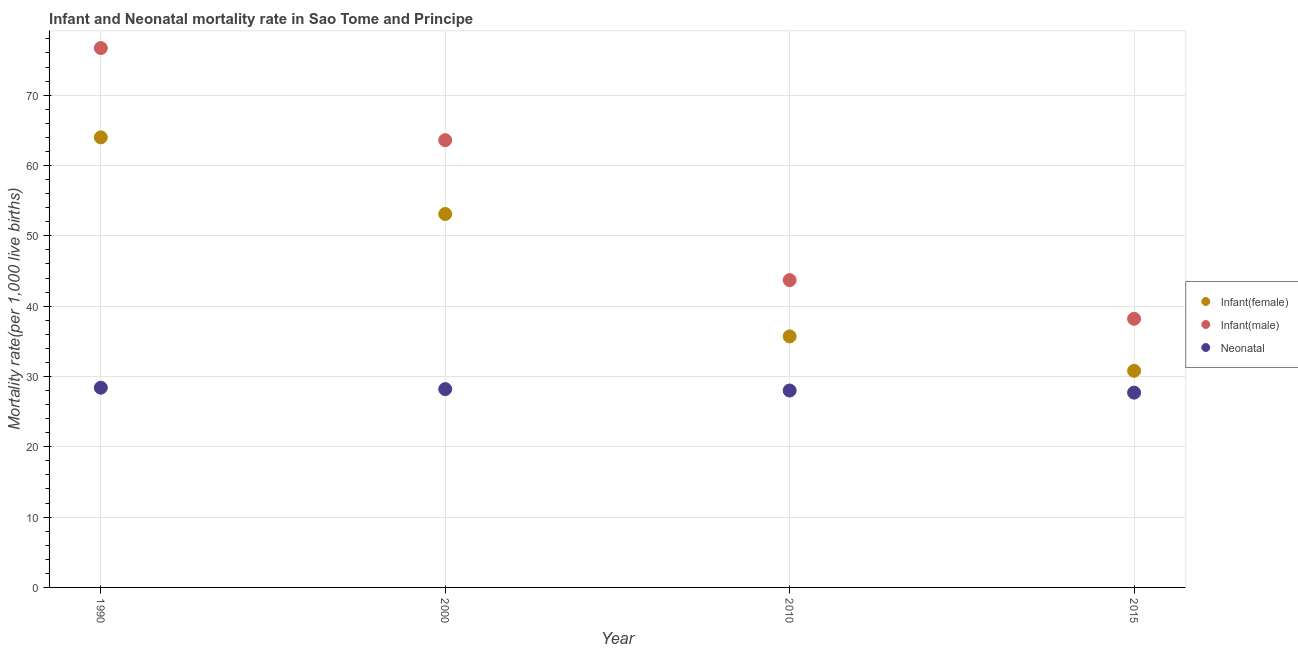Is the number of dotlines equal to the number of legend labels?
Your response must be concise. Yes. What is the infant mortality rate(male) in 2010?
Provide a succinct answer. 43.7. Across all years, what is the maximum infant mortality rate(female)?
Keep it short and to the point. 64. Across all years, what is the minimum infant mortality rate(female)?
Give a very brief answer. 30.8. In which year was the neonatal mortality rate minimum?
Give a very brief answer. 2015. What is the total infant mortality rate(female) in the graph?
Give a very brief answer. 183.6. What is the difference between the neonatal mortality rate in 2000 and that in 2010?
Your answer should be compact. 0.2. What is the difference between the infant mortality rate(female) in 2010 and the neonatal mortality rate in 1990?
Your answer should be compact. 7.3. What is the average infant mortality rate(female) per year?
Give a very brief answer. 45.9. In the year 2015, what is the difference between the neonatal mortality rate and infant mortality rate(male)?
Ensure brevity in your answer.  -10.5. What is the ratio of the neonatal mortality rate in 2000 to that in 2015?
Your answer should be compact. 1.02. What is the difference between the highest and the second highest infant mortality rate(female)?
Make the answer very short. 10.9. What is the difference between the highest and the lowest neonatal mortality rate?
Offer a very short reply. 0.7. In how many years, is the neonatal mortality rate greater than the average neonatal mortality rate taken over all years?
Your answer should be compact. 2. Is the sum of the infant mortality rate(male) in 2000 and 2015 greater than the maximum infant mortality rate(female) across all years?
Provide a short and direct response. Yes. What is the difference between two consecutive major ticks on the Y-axis?
Offer a terse response. 10. Does the graph contain any zero values?
Keep it short and to the point. No. Does the graph contain grids?
Your response must be concise. Yes. Where does the legend appear in the graph?
Ensure brevity in your answer.  Center right. How many legend labels are there?
Your response must be concise. 3. How are the legend labels stacked?
Your answer should be compact. Vertical. What is the title of the graph?
Offer a terse response. Infant and Neonatal mortality rate in Sao Tome and Principe. Does "Social insurance" appear as one of the legend labels in the graph?
Your answer should be very brief. No. What is the label or title of the Y-axis?
Your response must be concise. Mortality rate(per 1,0 live births). What is the Mortality rate(per 1,000 live births) in Infant(male) in 1990?
Ensure brevity in your answer.  76.7. What is the Mortality rate(per 1,000 live births) in Neonatal  in 1990?
Keep it short and to the point. 28.4. What is the Mortality rate(per 1,000 live births) of Infant(female) in 2000?
Provide a succinct answer. 53.1. What is the Mortality rate(per 1,000 live births) in Infant(male) in 2000?
Ensure brevity in your answer.  63.6. What is the Mortality rate(per 1,000 live births) of Neonatal  in 2000?
Give a very brief answer. 28.2. What is the Mortality rate(per 1,000 live births) in Infant(female) in 2010?
Your answer should be compact. 35.7. What is the Mortality rate(per 1,000 live births) of Infant(male) in 2010?
Keep it short and to the point. 43.7. What is the Mortality rate(per 1,000 live births) of Neonatal  in 2010?
Ensure brevity in your answer.  28. What is the Mortality rate(per 1,000 live births) of Infant(female) in 2015?
Offer a very short reply. 30.8. What is the Mortality rate(per 1,000 live births) in Infant(male) in 2015?
Your response must be concise. 38.2. What is the Mortality rate(per 1,000 live births) of Neonatal  in 2015?
Give a very brief answer. 27.7. Across all years, what is the maximum Mortality rate(per 1,000 live births) in Infant(female)?
Your answer should be compact. 64. Across all years, what is the maximum Mortality rate(per 1,000 live births) of Infant(male)?
Your answer should be very brief. 76.7. Across all years, what is the maximum Mortality rate(per 1,000 live births) in Neonatal ?
Offer a terse response. 28.4. Across all years, what is the minimum Mortality rate(per 1,000 live births) in Infant(female)?
Your answer should be compact. 30.8. Across all years, what is the minimum Mortality rate(per 1,000 live births) in Infant(male)?
Provide a succinct answer. 38.2. Across all years, what is the minimum Mortality rate(per 1,000 live births) in Neonatal ?
Your response must be concise. 27.7. What is the total Mortality rate(per 1,000 live births) of Infant(female) in the graph?
Your answer should be compact. 183.6. What is the total Mortality rate(per 1,000 live births) of Infant(male) in the graph?
Keep it short and to the point. 222.2. What is the total Mortality rate(per 1,000 live births) in Neonatal  in the graph?
Ensure brevity in your answer.  112.3. What is the difference between the Mortality rate(per 1,000 live births) of Neonatal  in 1990 and that in 2000?
Your answer should be very brief. 0.2. What is the difference between the Mortality rate(per 1,000 live births) in Infant(female) in 1990 and that in 2010?
Make the answer very short. 28.3. What is the difference between the Mortality rate(per 1,000 live births) of Neonatal  in 1990 and that in 2010?
Provide a succinct answer. 0.4. What is the difference between the Mortality rate(per 1,000 live births) in Infant(female) in 1990 and that in 2015?
Your response must be concise. 33.2. What is the difference between the Mortality rate(per 1,000 live births) of Infant(male) in 1990 and that in 2015?
Provide a short and direct response. 38.5. What is the difference between the Mortality rate(per 1,000 live births) in Neonatal  in 1990 and that in 2015?
Offer a terse response. 0.7. What is the difference between the Mortality rate(per 1,000 live births) of Neonatal  in 2000 and that in 2010?
Make the answer very short. 0.2. What is the difference between the Mortality rate(per 1,000 live births) of Infant(female) in 2000 and that in 2015?
Make the answer very short. 22.3. What is the difference between the Mortality rate(per 1,000 live births) in Infant(male) in 2000 and that in 2015?
Your answer should be compact. 25.4. What is the difference between the Mortality rate(per 1,000 live births) of Neonatal  in 2000 and that in 2015?
Provide a short and direct response. 0.5. What is the difference between the Mortality rate(per 1,000 live births) in Infant(female) in 2010 and that in 2015?
Your answer should be compact. 4.9. What is the difference between the Mortality rate(per 1,000 live births) in Infant(male) in 2010 and that in 2015?
Make the answer very short. 5.5. What is the difference between the Mortality rate(per 1,000 live births) of Neonatal  in 2010 and that in 2015?
Make the answer very short. 0.3. What is the difference between the Mortality rate(per 1,000 live births) of Infant(female) in 1990 and the Mortality rate(per 1,000 live births) of Neonatal  in 2000?
Ensure brevity in your answer.  35.8. What is the difference between the Mortality rate(per 1,000 live births) in Infant(male) in 1990 and the Mortality rate(per 1,000 live births) in Neonatal  in 2000?
Offer a terse response. 48.5. What is the difference between the Mortality rate(per 1,000 live births) of Infant(female) in 1990 and the Mortality rate(per 1,000 live births) of Infant(male) in 2010?
Your answer should be compact. 20.3. What is the difference between the Mortality rate(per 1,000 live births) in Infant(male) in 1990 and the Mortality rate(per 1,000 live births) in Neonatal  in 2010?
Ensure brevity in your answer.  48.7. What is the difference between the Mortality rate(per 1,000 live births) of Infant(female) in 1990 and the Mortality rate(per 1,000 live births) of Infant(male) in 2015?
Your answer should be compact. 25.8. What is the difference between the Mortality rate(per 1,000 live births) of Infant(female) in 1990 and the Mortality rate(per 1,000 live births) of Neonatal  in 2015?
Provide a short and direct response. 36.3. What is the difference between the Mortality rate(per 1,000 live births) in Infant(male) in 1990 and the Mortality rate(per 1,000 live births) in Neonatal  in 2015?
Offer a terse response. 49. What is the difference between the Mortality rate(per 1,000 live births) of Infant(female) in 2000 and the Mortality rate(per 1,000 live births) of Neonatal  in 2010?
Make the answer very short. 25.1. What is the difference between the Mortality rate(per 1,000 live births) in Infant(male) in 2000 and the Mortality rate(per 1,000 live births) in Neonatal  in 2010?
Your response must be concise. 35.6. What is the difference between the Mortality rate(per 1,000 live births) in Infant(female) in 2000 and the Mortality rate(per 1,000 live births) in Neonatal  in 2015?
Provide a short and direct response. 25.4. What is the difference between the Mortality rate(per 1,000 live births) of Infant(male) in 2000 and the Mortality rate(per 1,000 live births) of Neonatal  in 2015?
Make the answer very short. 35.9. What is the difference between the Mortality rate(per 1,000 live births) of Infant(male) in 2010 and the Mortality rate(per 1,000 live births) of Neonatal  in 2015?
Your answer should be compact. 16. What is the average Mortality rate(per 1,000 live births) of Infant(female) per year?
Keep it short and to the point. 45.9. What is the average Mortality rate(per 1,000 live births) of Infant(male) per year?
Provide a succinct answer. 55.55. What is the average Mortality rate(per 1,000 live births) in Neonatal  per year?
Provide a short and direct response. 28.07. In the year 1990, what is the difference between the Mortality rate(per 1,000 live births) in Infant(female) and Mortality rate(per 1,000 live births) in Neonatal ?
Provide a succinct answer. 35.6. In the year 1990, what is the difference between the Mortality rate(per 1,000 live births) in Infant(male) and Mortality rate(per 1,000 live births) in Neonatal ?
Provide a succinct answer. 48.3. In the year 2000, what is the difference between the Mortality rate(per 1,000 live births) of Infant(female) and Mortality rate(per 1,000 live births) of Neonatal ?
Keep it short and to the point. 24.9. In the year 2000, what is the difference between the Mortality rate(per 1,000 live births) in Infant(male) and Mortality rate(per 1,000 live births) in Neonatal ?
Keep it short and to the point. 35.4. In the year 2010, what is the difference between the Mortality rate(per 1,000 live births) in Infant(female) and Mortality rate(per 1,000 live births) in Infant(male)?
Provide a succinct answer. -8. In the year 2010, what is the difference between the Mortality rate(per 1,000 live births) of Infant(female) and Mortality rate(per 1,000 live births) of Neonatal ?
Provide a succinct answer. 7.7. In the year 2010, what is the difference between the Mortality rate(per 1,000 live births) of Infant(male) and Mortality rate(per 1,000 live births) of Neonatal ?
Give a very brief answer. 15.7. In the year 2015, what is the difference between the Mortality rate(per 1,000 live births) in Infant(female) and Mortality rate(per 1,000 live births) in Infant(male)?
Offer a terse response. -7.4. What is the ratio of the Mortality rate(per 1,000 live births) in Infant(female) in 1990 to that in 2000?
Keep it short and to the point. 1.21. What is the ratio of the Mortality rate(per 1,000 live births) of Infant(male) in 1990 to that in 2000?
Provide a succinct answer. 1.21. What is the ratio of the Mortality rate(per 1,000 live births) of Neonatal  in 1990 to that in 2000?
Your response must be concise. 1.01. What is the ratio of the Mortality rate(per 1,000 live births) in Infant(female) in 1990 to that in 2010?
Keep it short and to the point. 1.79. What is the ratio of the Mortality rate(per 1,000 live births) of Infant(male) in 1990 to that in 2010?
Offer a very short reply. 1.76. What is the ratio of the Mortality rate(per 1,000 live births) in Neonatal  in 1990 to that in 2010?
Keep it short and to the point. 1.01. What is the ratio of the Mortality rate(per 1,000 live births) in Infant(female) in 1990 to that in 2015?
Your answer should be compact. 2.08. What is the ratio of the Mortality rate(per 1,000 live births) in Infant(male) in 1990 to that in 2015?
Make the answer very short. 2.01. What is the ratio of the Mortality rate(per 1,000 live births) of Neonatal  in 1990 to that in 2015?
Offer a very short reply. 1.03. What is the ratio of the Mortality rate(per 1,000 live births) of Infant(female) in 2000 to that in 2010?
Keep it short and to the point. 1.49. What is the ratio of the Mortality rate(per 1,000 live births) of Infant(male) in 2000 to that in 2010?
Provide a succinct answer. 1.46. What is the ratio of the Mortality rate(per 1,000 live births) of Neonatal  in 2000 to that in 2010?
Keep it short and to the point. 1.01. What is the ratio of the Mortality rate(per 1,000 live births) in Infant(female) in 2000 to that in 2015?
Your response must be concise. 1.72. What is the ratio of the Mortality rate(per 1,000 live births) in Infant(male) in 2000 to that in 2015?
Offer a very short reply. 1.66. What is the ratio of the Mortality rate(per 1,000 live births) in Neonatal  in 2000 to that in 2015?
Provide a short and direct response. 1.02. What is the ratio of the Mortality rate(per 1,000 live births) in Infant(female) in 2010 to that in 2015?
Offer a very short reply. 1.16. What is the ratio of the Mortality rate(per 1,000 live births) in Infant(male) in 2010 to that in 2015?
Offer a terse response. 1.14. What is the ratio of the Mortality rate(per 1,000 live births) of Neonatal  in 2010 to that in 2015?
Offer a terse response. 1.01. What is the difference between the highest and the second highest Mortality rate(per 1,000 live births) in Infant(female)?
Offer a terse response. 10.9. What is the difference between the highest and the second highest Mortality rate(per 1,000 live births) in Infant(male)?
Offer a very short reply. 13.1. What is the difference between the highest and the lowest Mortality rate(per 1,000 live births) in Infant(female)?
Give a very brief answer. 33.2. What is the difference between the highest and the lowest Mortality rate(per 1,000 live births) in Infant(male)?
Keep it short and to the point. 38.5. 